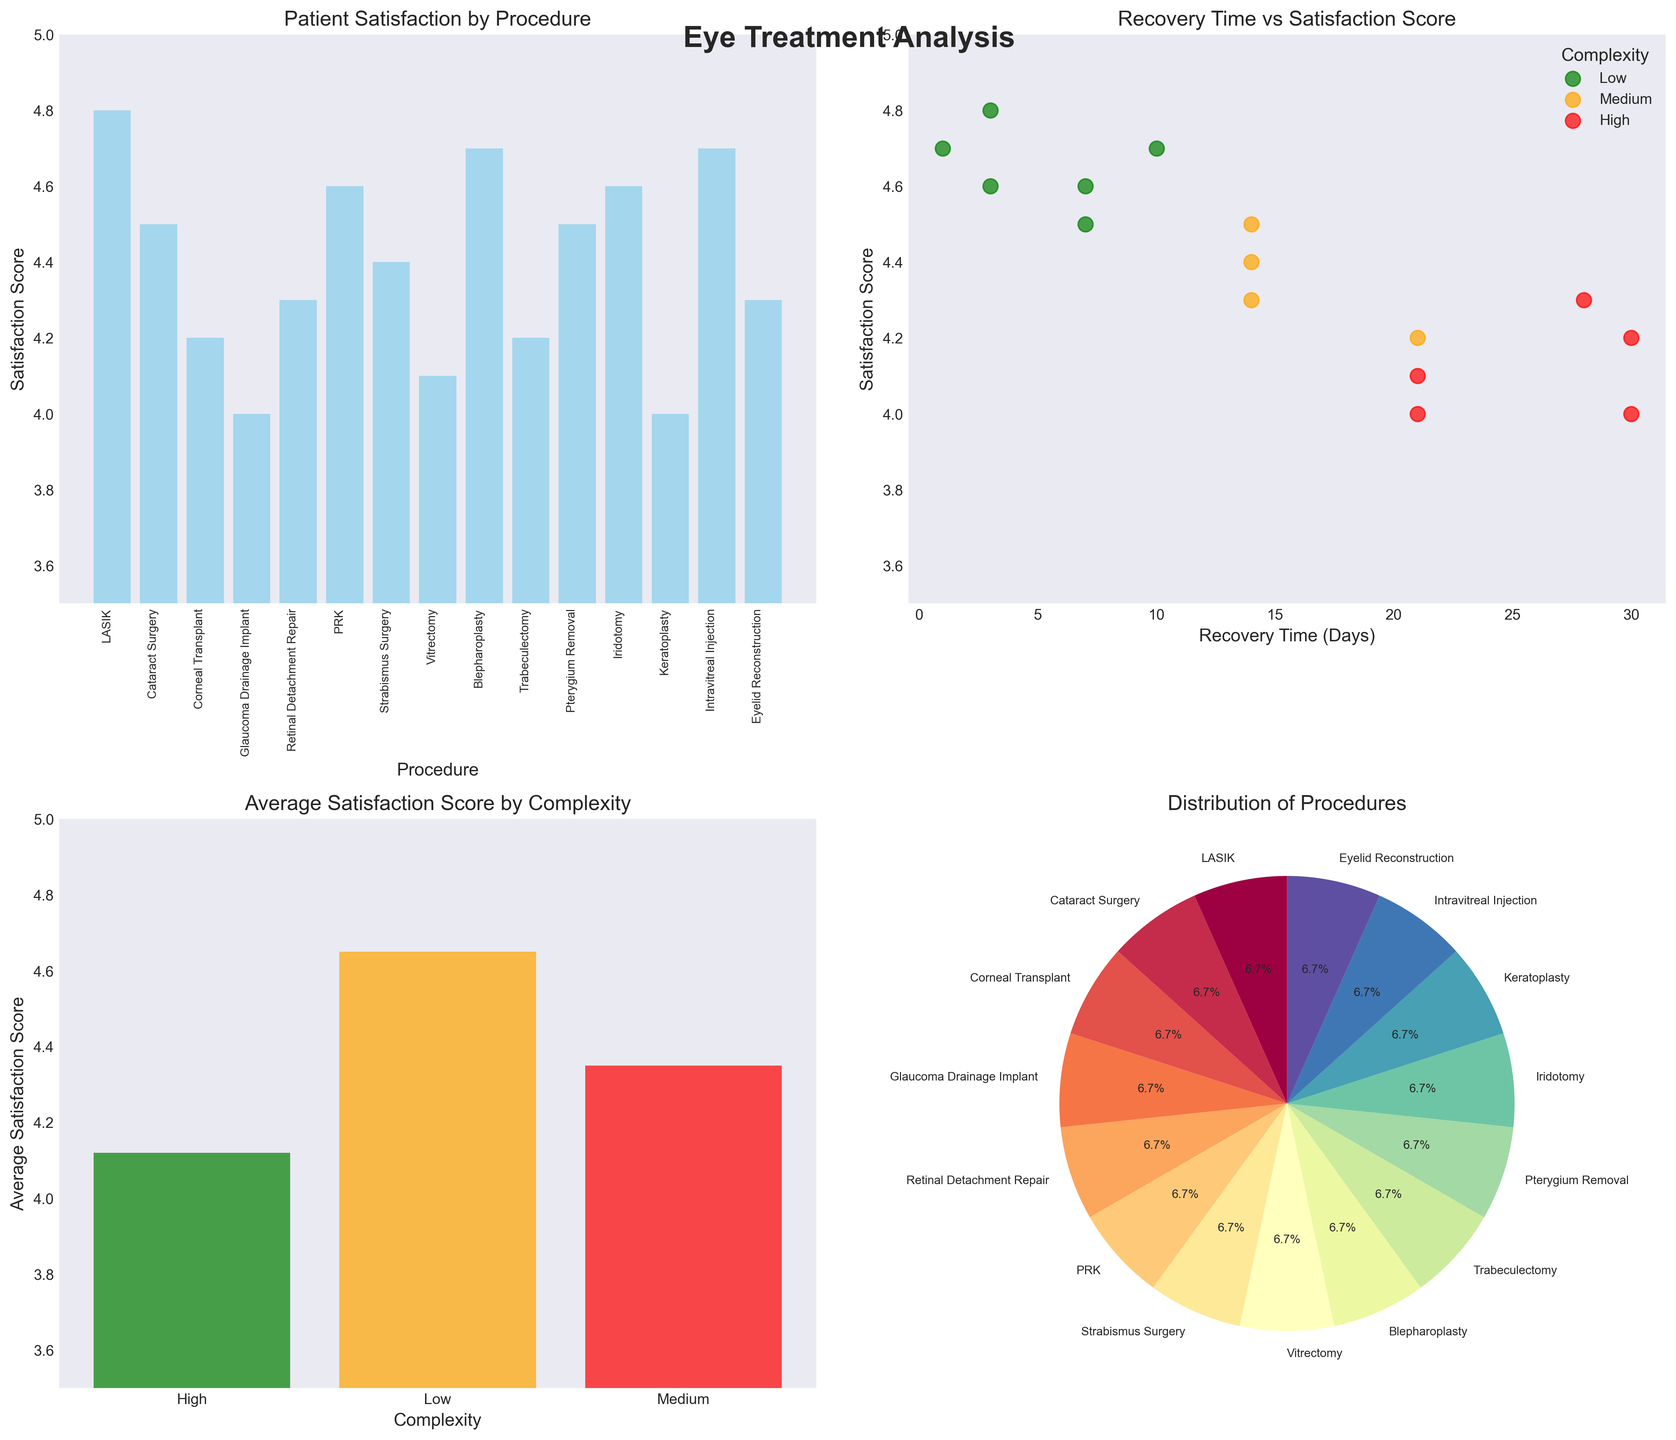What is the highest patient satisfaction score among the procedures? By looking at the bar chart in the first subplot, we can observe the height of the bars to identify the highest score. The bar for LASIK reaches the top scoring 4.8, which is the tallest bar in the chart.
Answer: 4.8 Which procedure has the longest recovery time? From the scatter plot in subplot 2, we can see that the procedure with the longest recovery time is the one farthest to the right on the x-axis. Corneal Transplant and Keratoplasty both have the longest recovery time of 30 days.
Answer: Corneal Transplant, Keratoplasty What is the average patient satisfaction score for high-complexity procedures? Referring to the grouped bar chart in subplot 3, the bar corresponding to high complexity shows an average satisfaction score of approximately 4.1.
Answer: 4.1 Which has a higher average satisfaction score, medium or low-complexity procedures? From subplot 3, we can compare the height of the bars for medium and low complexity. Low-complexity procedures have a higher average satisfaction score.
Answer: Low-complexity procedures How many types of procedures have a recovery time of less than 10 days? By examining the scatter plot in subplot 2, we count the number of data points that are on or to the left of 10 days on the x-axis. There are 6 such data points.
Answer: 6 Which procedure has the lowest patient satisfaction score? By looking at the bar chart in subplot 1, the shortest bar represents the lowest satisfaction score. This bar is for Keratoplasty with a score of 4.0.
Answer: Keratoplasty How does the distribution of procedures appear? The pie chart in subplot 4 shows the proportions of different procedures. Each slice of the pie represents a procedure type, illustrating how procedures are distributed.
Answer: Diverse distribution What is the title of the grouped bar chart? The title of the grouped bar chart is directly above it in subplot 3. It reads, "Average Satisfaction Score by Complexity."
Answer: Average Satisfaction Score by Complexity How is patient satisfaction related to recovery time for high-complexity procedures? From the scatter plot in subplot 2, we can see that for high-complexity procedures (represented by red points), there seems to be a slight downward trend in satisfaction scores as recovery time increases, but it is not very pronounced.
Answer: Slight downward trend 